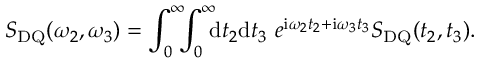Convert formula to latex. <formula><loc_0><loc_0><loc_500><loc_500>S _ { D Q } ( \omega _ { 2 } , \omega _ { 3 } ) = \int _ { 0 } ^ { \infty } \, \int _ { 0 } ^ { \infty } \, { d } t _ { 2 } { d } t _ { 3 } \ e ^ { { i } \omega _ { 2 } t _ { 2 } + { i } \omega _ { 3 } t _ { 3 } } S _ { D Q } ( t _ { 2 } , t _ { 3 } ) .</formula> 